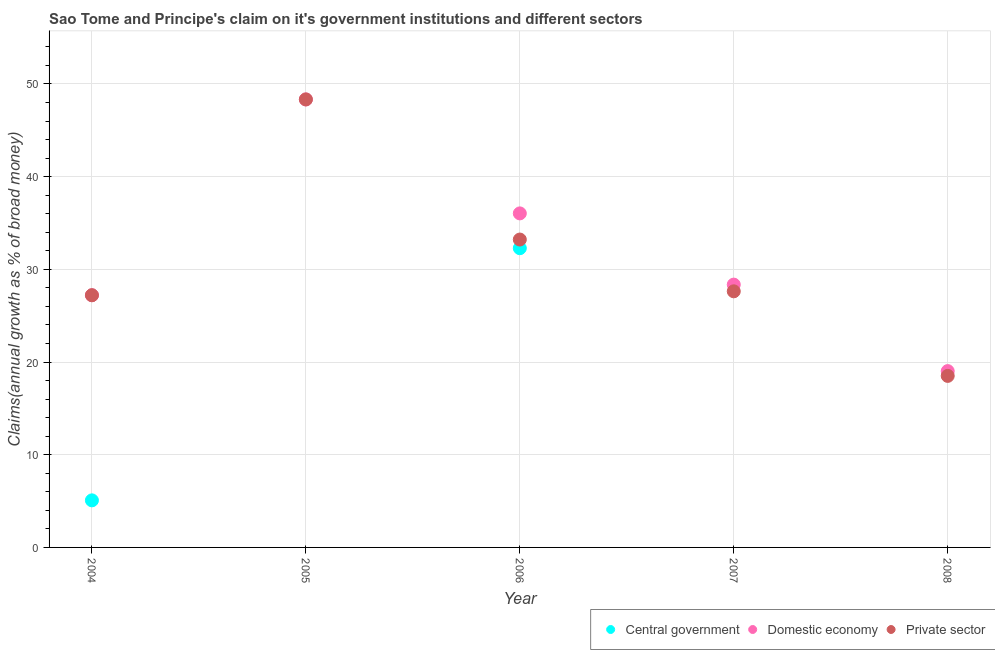What is the percentage of claim on the central government in 2008?
Provide a short and direct response. 0. Across all years, what is the maximum percentage of claim on the domestic economy?
Your response must be concise. 48.33. Across all years, what is the minimum percentage of claim on the private sector?
Provide a short and direct response. 18.51. In which year was the percentage of claim on the domestic economy maximum?
Make the answer very short. 2005. What is the total percentage of claim on the domestic economy in the graph?
Offer a terse response. 158.96. What is the difference between the percentage of claim on the private sector in 2004 and that in 2008?
Keep it short and to the point. 8.7. What is the difference between the percentage of claim on the domestic economy in 2007 and the percentage of claim on the central government in 2008?
Provide a succinct answer. 28.35. What is the average percentage of claim on the private sector per year?
Give a very brief answer. 30.98. In the year 2004, what is the difference between the percentage of claim on the domestic economy and percentage of claim on the central government?
Offer a very short reply. 22.13. In how many years, is the percentage of claim on the private sector greater than 10 %?
Provide a short and direct response. 5. What is the ratio of the percentage of claim on the domestic economy in 2006 to that in 2007?
Ensure brevity in your answer.  1.27. What is the difference between the highest and the second highest percentage of claim on the private sector?
Provide a succinct answer. 15.12. What is the difference between the highest and the lowest percentage of claim on the central government?
Offer a very short reply. 32.28. In how many years, is the percentage of claim on the central government greater than the average percentage of claim on the central government taken over all years?
Provide a short and direct response. 1. Does the percentage of claim on the domestic economy monotonically increase over the years?
Offer a terse response. No. Is the percentage of claim on the domestic economy strictly greater than the percentage of claim on the private sector over the years?
Your response must be concise. No. How many dotlines are there?
Keep it short and to the point. 3. How many years are there in the graph?
Give a very brief answer. 5. Does the graph contain grids?
Your answer should be very brief. Yes. What is the title of the graph?
Provide a succinct answer. Sao Tome and Principe's claim on it's government institutions and different sectors. Does "Other sectors" appear as one of the legend labels in the graph?
Your response must be concise. No. What is the label or title of the X-axis?
Ensure brevity in your answer.  Year. What is the label or title of the Y-axis?
Your answer should be very brief. Claims(annual growth as % of broad money). What is the Claims(annual growth as % of broad money) in Central government in 2004?
Give a very brief answer. 5.08. What is the Claims(annual growth as % of broad money) in Domestic economy in 2004?
Provide a succinct answer. 27.21. What is the Claims(annual growth as % of broad money) in Private sector in 2004?
Provide a succinct answer. 27.21. What is the Claims(annual growth as % of broad money) of Central government in 2005?
Keep it short and to the point. 0. What is the Claims(annual growth as % of broad money) of Domestic economy in 2005?
Your response must be concise. 48.33. What is the Claims(annual growth as % of broad money) of Private sector in 2005?
Give a very brief answer. 48.33. What is the Claims(annual growth as % of broad money) in Central government in 2006?
Keep it short and to the point. 32.28. What is the Claims(annual growth as % of broad money) in Domestic economy in 2006?
Offer a very short reply. 36.04. What is the Claims(annual growth as % of broad money) in Private sector in 2006?
Ensure brevity in your answer.  33.22. What is the Claims(annual growth as % of broad money) of Domestic economy in 2007?
Ensure brevity in your answer.  28.35. What is the Claims(annual growth as % of broad money) of Private sector in 2007?
Offer a very short reply. 27.63. What is the Claims(annual growth as % of broad money) in Domestic economy in 2008?
Your answer should be compact. 19.02. What is the Claims(annual growth as % of broad money) in Private sector in 2008?
Ensure brevity in your answer.  18.51. Across all years, what is the maximum Claims(annual growth as % of broad money) of Central government?
Your response must be concise. 32.28. Across all years, what is the maximum Claims(annual growth as % of broad money) of Domestic economy?
Offer a very short reply. 48.33. Across all years, what is the maximum Claims(annual growth as % of broad money) in Private sector?
Provide a succinct answer. 48.33. Across all years, what is the minimum Claims(annual growth as % of broad money) in Domestic economy?
Offer a very short reply. 19.02. Across all years, what is the minimum Claims(annual growth as % of broad money) of Private sector?
Provide a short and direct response. 18.51. What is the total Claims(annual growth as % of broad money) of Central government in the graph?
Give a very brief answer. 37.36. What is the total Claims(annual growth as % of broad money) in Domestic economy in the graph?
Provide a succinct answer. 158.96. What is the total Claims(annual growth as % of broad money) in Private sector in the graph?
Offer a very short reply. 154.89. What is the difference between the Claims(annual growth as % of broad money) in Domestic economy in 2004 and that in 2005?
Provide a short and direct response. -21.12. What is the difference between the Claims(annual growth as % of broad money) in Private sector in 2004 and that in 2005?
Your answer should be very brief. -21.12. What is the difference between the Claims(annual growth as % of broad money) in Central government in 2004 and that in 2006?
Offer a very short reply. -27.21. What is the difference between the Claims(annual growth as % of broad money) of Domestic economy in 2004 and that in 2006?
Your answer should be very brief. -8.83. What is the difference between the Claims(annual growth as % of broad money) of Private sector in 2004 and that in 2006?
Your response must be concise. -6.01. What is the difference between the Claims(annual growth as % of broad money) of Domestic economy in 2004 and that in 2007?
Your answer should be very brief. -1.15. What is the difference between the Claims(annual growth as % of broad money) in Private sector in 2004 and that in 2007?
Give a very brief answer. -0.42. What is the difference between the Claims(annual growth as % of broad money) of Domestic economy in 2004 and that in 2008?
Make the answer very short. 8.18. What is the difference between the Claims(annual growth as % of broad money) in Private sector in 2004 and that in 2008?
Give a very brief answer. 8.7. What is the difference between the Claims(annual growth as % of broad money) of Domestic economy in 2005 and that in 2006?
Keep it short and to the point. 12.29. What is the difference between the Claims(annual growth as % of broad money) of Private sector in 2005 and that in 2006?
Provide a succinct answer. 15.12. What is the difference between the Claims(annual growth as % of broad money) in Domestic economy in 2005 and that in 2007?
Make the answer very short. 19.98. What is the difference between the Claims(annual growth as % of broad money) of Private sector in 2005 and that in 2007?
Ensure brevity in your answer.  20.7. What is the difference between the Claims(annual growth as % of broad money) in Domestic economy in 2005 and that in 2008?
Offer a very short reply. 29.31. What is the difference between the Claims(annual growth as % of broad money) of Private sector in 2005 and that in 2008?
Offer a terse response. 29.83. What is the difference between the Claims(annual growth as % of broad money) in Domestic economy in 2006 and that in 2007?
Provide a succinct answer. 7.68. What is the difference between the Claims(annual growth as % of broad money) of Private sector in 2006 and that in 2007?
Offer a terse response. 5.59. What is the difference between the Claims(annual growth as % of broad money) of Domestic economy in 2006 and that in 2008?
Offer a very short reply. 17.01. What is the difference between the Claims(annual growth as % of broad money) of Private sector in 2006 and that in 2008?
Make the answer very short. 14.71. What is the difference between the Claims(annual growth as % of broad money) in Domestic economy in 2007 and that in 2008?
Offer a terse response. 9.33. What is the difference between the Claims(annual growth as % of broad money) in Private sector in 2007 and that in 2008?
Your response must be concise. 9.12. What is the difference between the Claims(annual growth as % of broad money) in Central government in 2004 and the Claims(annual growth as % of broad money) in Domestic economy in 2005?
Offer a very short reply. -43.26. What is the difference between the Claims(annual growth as % of broad money) in Central government in 2004 and the Claims(annual growth as % of broad money) in Private sector in 2005?
Offer a terse response. -43.26. What is the difference between the Claims(annual growth as % of broad money) in Domestic economy in 2004 and the Claims(annual growth as % of broad money) in Private sector in 2005?
Your answer should be compact. -21.12. What is the difference between the Claims(annual growth as % of broad money) of Central government in 2004 and the Claims(annual growth as % of broad money) of Domestic economy in 2006?
Offer a very short reply. -30.96. What is the difference between the Claims(annual growth as % of broad money) in Central government in 2004 and the Claims(annual growth as % of broad money) in Private sector in 2006?
Offer a terse response. -28.14. What is the difference between the Claims(annual growth as % of broad money) of Domestic economy in 2004 and the Claims(annual growth as % of broad money) of Private sector in 2006?
Offer a very short reply. -6.01. What is the difference between the Claims(annual growth as % of broad money) of Central government in 2004 and the Claims(annual growth as % of broad money) of Domestic economy in 2007?
Provide a succinct answer. -23.28. What is the difference between the Claims(annual growth as % of broad money) in Central government in 2004 and the Claims(annual growth as % of broad money) in Private sector in 2007?
Your answer should be very brief. -22.55. What is the difference between the Claims(annual growth as % of broad money) in Domestic economy in 2004 and the Claims(annual growth as % of broad money) in Private sector in 2007?
Offer a very short reply. -0.42. What is the difference between the Claims(annual growth as % of broad money) of Central government in 2004 and the Claims(annual growth as % of broad money) of Domestic economy in 2008?
Offer a very short reply. -13.95. What is the difference between the Claims(annual growth as % of broad money) in Central government in 2004 and the Claims(annual growth as % of broad money) in Private sector in 2008?
Offer a very short reply. -13.43. What is the difference between the Claims(annual growth as % of broad money) of Domestic economy in 2004 and the Claims(annual growth as % of broad money) of Private sector in 2008?
Offer a terse response. 8.7. What is the difference between the Claims(annual growth as % of broad money) of Domestic economy in 2005 and the Claims(annual growth as % of broad money) of Private sector in 2006?
Provide a succinct answer. 15.12. What is the difference between the Claims(annual growth as % of broad money) of Domestic economy in 2005 and the Claims(annual growth as % of broad money) of Private sector in 2007?
Give a very brief answer. 20.7. What is the difference between the Claims(annual growth as % of broad money) of Domestic economy in 2005 and the Claims(annual growth as % of broad money) of Private sector in 2008?
Provide a short and direct response. 29.83. What is the difference between the Claims(annual growth as % of broad money) of Central government in 2006 and the Claims(annual growth as % of broad money) of Domestic economy in 2007?
Provide a short and direct response. 3.93. What is the difference between the Claims(annual growth as % of broad money) in Central government in 2006 and the Claims(annual growth as % of broad money) in Private sector in 2007?
Provide a succinct answer. 4.65. What is the difference between the Claims(annual growth as % of broad money) of Domestic economy in 2006 and the Claims(annual growth as % of broad money) of Private sector in 2007?
Offer a terse response. 8.41. What is the difference between the Claims(annual growth as % of broad money) of Central government in 2006 and the Claims(annual growth as % of broad money) of Domestic economy in 2008?
Ensure brevity in your answer.  13.26. What is the difference between the Claims(annual growth as % of broad money) in Central government in 2006 and the Claims(annual growth as % of broad money) in Private sector in 2008?
Offer a terse response. 13.78. What is the difference between the Claims(annual growth as % of broad money) of Domestic economy in 2006 and the Claims(annual growth as % of broad money) of Private sector in 2008?
Make the answer very short. 17.53. What is the difference between the Claims(annual growth as % of broad money) in Domestic economy in 2007 and the Claims(annual growth as % of broad money) in Private sector in 2008?
Your response must be concise. 9.85. What is the average Claims(annual growth as % of broad money) in Central government per year?
Make the answer very short. 7.47. What is the average Claims(annual growth as % of broad money) of Domestic economy per year?
Keep it short and to the point. 31.79. What is the average Claims(annual growth as % of broad money) in Private sector per year?
Your answer should be very brief. 30.98. In the year 2004, what is the difference between the Claims(annual growth as % of broad money) of Central government and Claims(annual growth as % of broad money) of Domestic economy?
Make the answer very short. -22.13. In the year 2004, what is the difference between the Claims(annual growth as % of broad money) of Central government and Claims(annual growth as % of broad money) of Private sector?
Provide a short and direct response. -22.13. In the year 2005, what is the difference between the Claims(annual growth as % of broad money) in Domestic economy and Claims(annual growth as % of broad money) in Private sector?
Provide a short and direct response. 0. In the year 2006, what is the difference between the Claims(annual growth as % of broad money) in Central government and Claims(annual growth as % of broad money) in Domestic economy?
Your answer should be very brief. -3.75. In the year 2006, what is the difference between the Claims(annual growth as % of broad money) of Central government and Claims(annual growth as % of broad money) of Private sector?
Make the answer very short. -0.93. In the year 2006, what is the difference between the Claims(annual growth as % of broad money) of Domestic economy and Claims(annual growth as % of broad money) of Private sector?
Provide a succinct answer. 2.82. In the year 2007, what is the difference between the Claims(annual growth as % of broad money) of Domestic economy and Claims(annual growth as % of broad money) of Private sector?
Ensure brevity in your answer.  0.72. In the year 2008, what is the difference between the Claims(annual growth as % of broad money) of Domestic economy and Claims(annual growth as % of broad money) of Private sector?
Provide a short and direct response. 0.52. What is the ratio of the Claims(annual growth as % of broad money) of Domestic economy in 2004 to that in 2005?
Your answer should be compact. 0.56. What is the ratio of the Claims(annual growth as % of broad money) of Private sector in 2004 to that in 2005?
Provide a short and direct response. 0.56. What is the ratio of the Claims(annual growth as % of broad money) in Central government in 2004 to that in 2006?
Keep it short and to the point. 0.16. What is the ratio of the Claims(annual growth as % of broad money) of Domestic economy in 2004 to that in 2006?
Make the answer very short. 0.76. What is the ratio of the Claims(annual growth as % of broad money) in Private sector in 2004 to that in 2006?
Offer a very short reply. 0.82. What is the ratio of the Claims(annual growth as % of broad money) in Domestic economy in 2004 to that in 2007?
Offer a very short reply. 0.96. What is the ratio of the Claims(annual growth as % of broad money) in Private sector in 2004 to that in 2007?
Your response must be concise. 0.98. What is the ratio of the Claims(annual growth as % of broad money) of Domestic economy in 2004 to that in 2008?
Your response must be concise. 1.43. What is the ratio of the Claims(annual growth as % of broad money) in Private sector in 2004 to that in 2008?
Your response must be concise. 1.47. What is the ratio of the Claims(annual growth as % of broad money) in Domestic economy in 2005 to that in 2006?
Provide a short and direct response. 1.34. What is the ratio of the Claims(annual growth as % of broad money) of Private sector in 2005 to that in 2006?
Keep it short and to the point. 1.46. What is the ratio of the Claims(annual growth as % of broad money) of Domestic economy in 2005 to that in 2007?
Your answer should be very brief. 1.7. What is the ratio of the Claims(annual growth as % of broad money) in Private sector in 2005 to that in 2007?
Provide a short and direct response. 1.75. What is the ratio of the Claims(annual growth as % of broad money) of Domestic economy in 2005 to that in 2008?
Give a very brief answer. 2.54. What is the ratio of the Claims(annual growth as % of broad money) in Private sector in 2005 to that in 2008?
Ensure brevity in your answer.  2.61. What is the ratio of the Claims(annual growth as % of broad money) of Domestic economy in 2006 to that in 2007?
Your answer should be compact. 1.27. What is the ratio of the Claims(annual growth as % of broad money) of Private sector in 2006 to that in 2007?
Offer a terse response. 1.2. What is the ratio of the Claims(annual growth as % of broad money) in Domestic economy in 2006 to that in 2008?
Provide a succinct answer. 1.89. What is the ratio of the Claims(annual growth as % of broad money) in Private sector in 2006 to that in 2008?
Give a very brief answer. 1.79. What is the ratio of the Claims(annual growth as % of broad money) in Domestic economy in 2007 to that in 2008?
Give a very brief answer. 1.49. What is the ratio of the Claims(annual growth as % of broad money) in Private sector in 2007 to that in 2008?
Keep it short and to the point. 1.49. What is the difference between the highest and the second highest Claims(annual growth as % of broad money) of Domestic economy?
Your answer should be compact. 12.29. What is the difference between the highest and the second highest Claims(annual growth as % of broad money) of Private sector?
Give a very brief answer. 15.12. What is the difference between the highest and the lowest Claims(annual growth as % of broad money) of Central government?
Offer a terse response. 32.28. What is the difference between the highest and the lowest Claims(annual growth as % of broad money) in Domestic economy?
Your answer should be compact. 29.31. What is the difference between the highest and the lowest Claims(annual growth as % of broad money) in Private sector?
Make the answer very short. 29.83. 